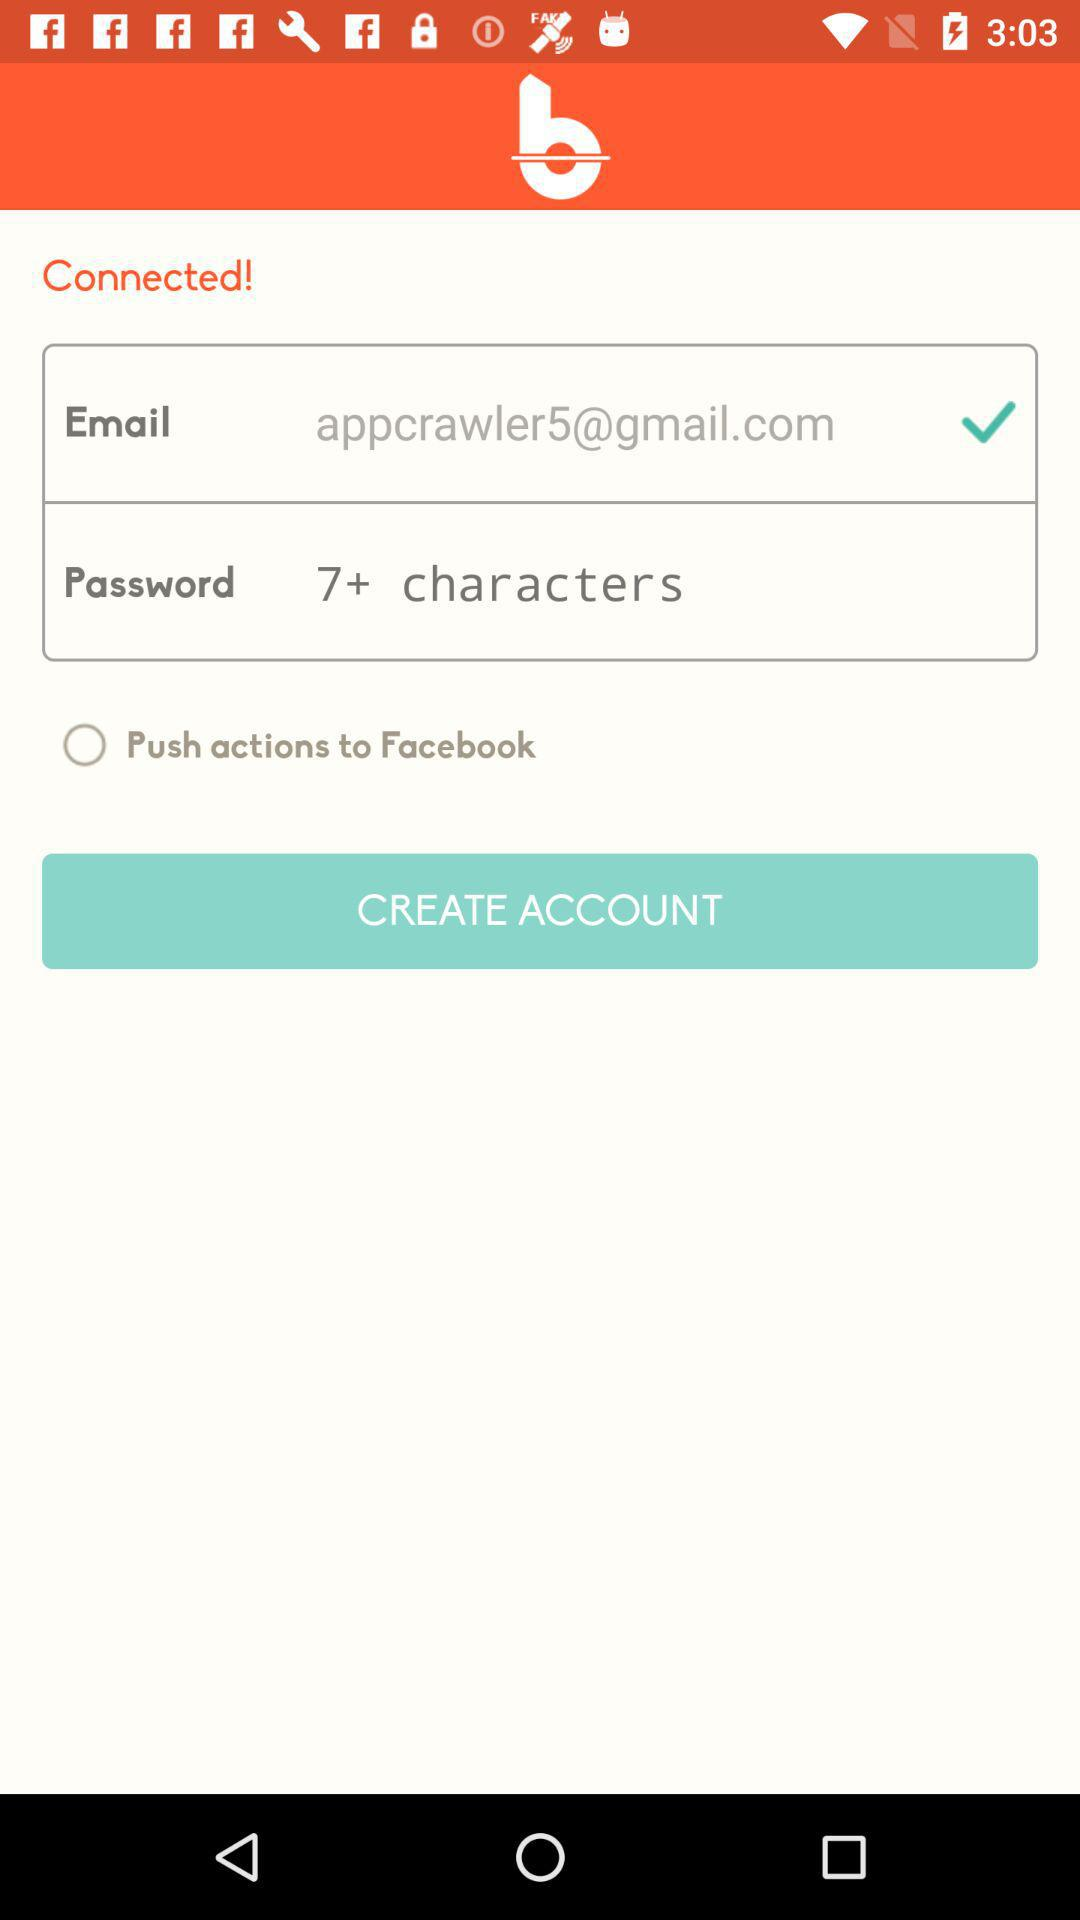What is the email address? The email address is appcrawler5@gmail.com. 